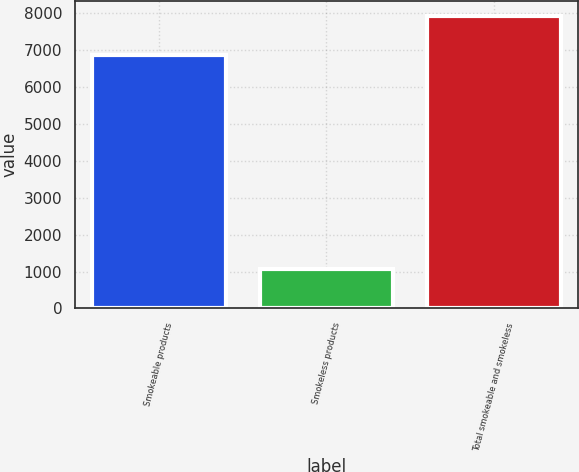<chart> <loc_0><loc_0><loc_500><loc_500><bar_chart><fcel>Smokeable products<fcel>Smokeless products<fcel>Total smokeable and smokeless<nl><fcel>6873<fcel>1061<fcel>7934<nl></chart> 